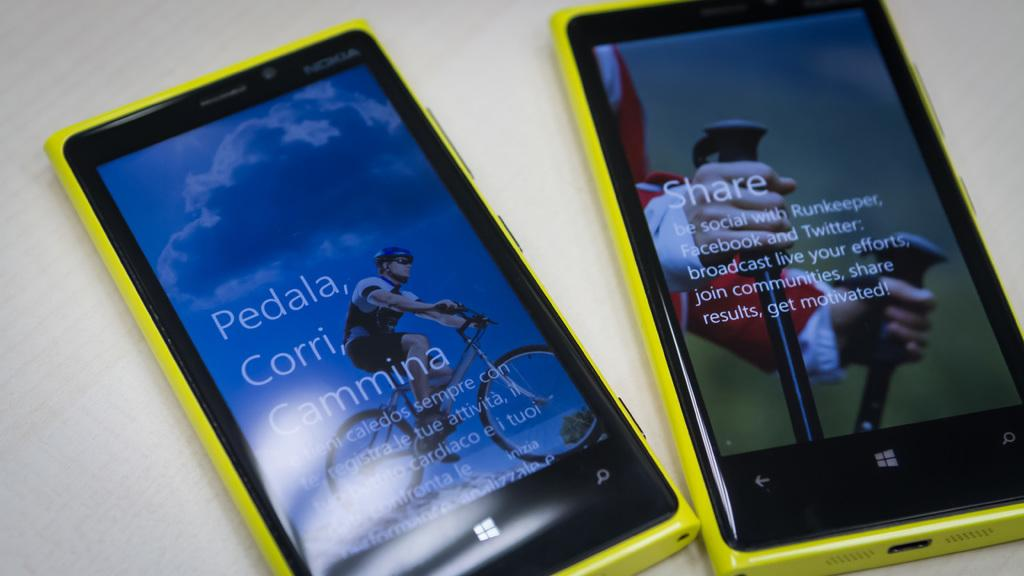<image>
Create a compact narrative representing the image presented. Two phones that both have yellow exteriors and are Window phones. 